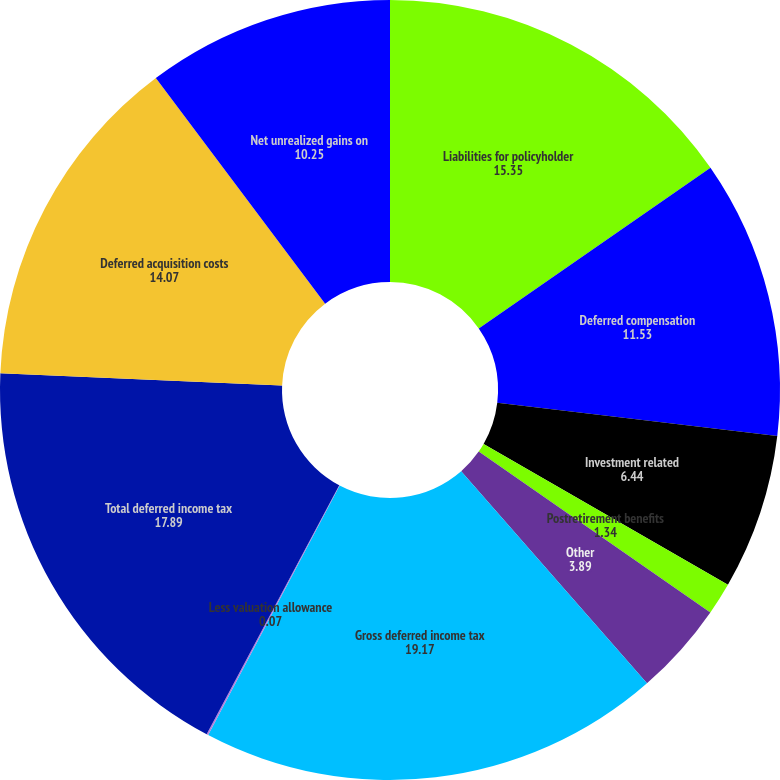Convert chart to OTSL. <chart><loc_0><loc_0><loc_500><loc_500><pie_chart><fcel>Liabilities for policyholder<fcel>Deferred compensation<fcel>Investment related<fcel>Postretirement benefits<fcel>Other<fcel>Gross deferred income tax<fcel>Less valuation allowance<fcel>Total deferred income tax<fcel>Deferred acquisition costs<fcel>Net unrealized gains on<nl><fcel>15.35%<fcel>11.53%<fcel>6.44%<fcel>1.34%<fcel>3.89%<fcel>19.17%<fcel>0.07%<fcel>17.89%<fcel>14.07%<fcel>10.25%<nl></chart> 